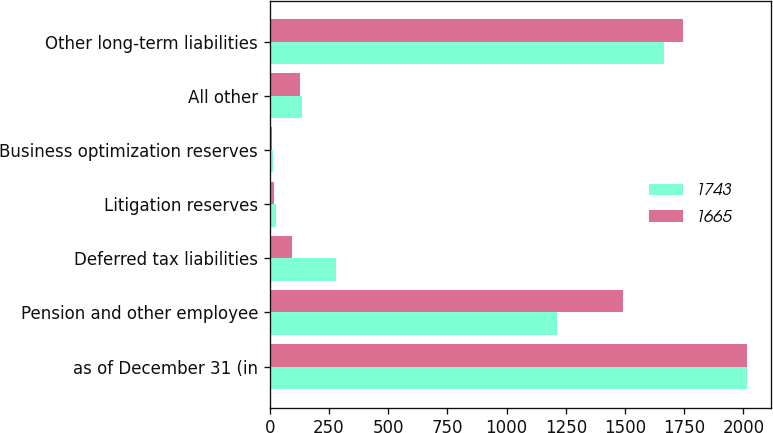Convert chart. <chart><loc_0><loc_0><loc_500><loc_500><stacked_bar_chart><ecel><fcel>as of December 31 (in<fcel>Pension and other employee<fcel>Deferred tax liabilities<fcel>Litigation reserves<fcel>Business optimization reserves<fcel>All other<fcel>Other long-term liabilities<nl><fcel>1743<fcel>2017<fcel>1211<fcel>280<fcel>27<fcel>12<fcel>135<fcel>1665<nl><fcel>1665<fcel>2016<fcel>1492<fcel>93<fcel>19<fcel>11<fcel>128<fcel>1743<nl></chart> 